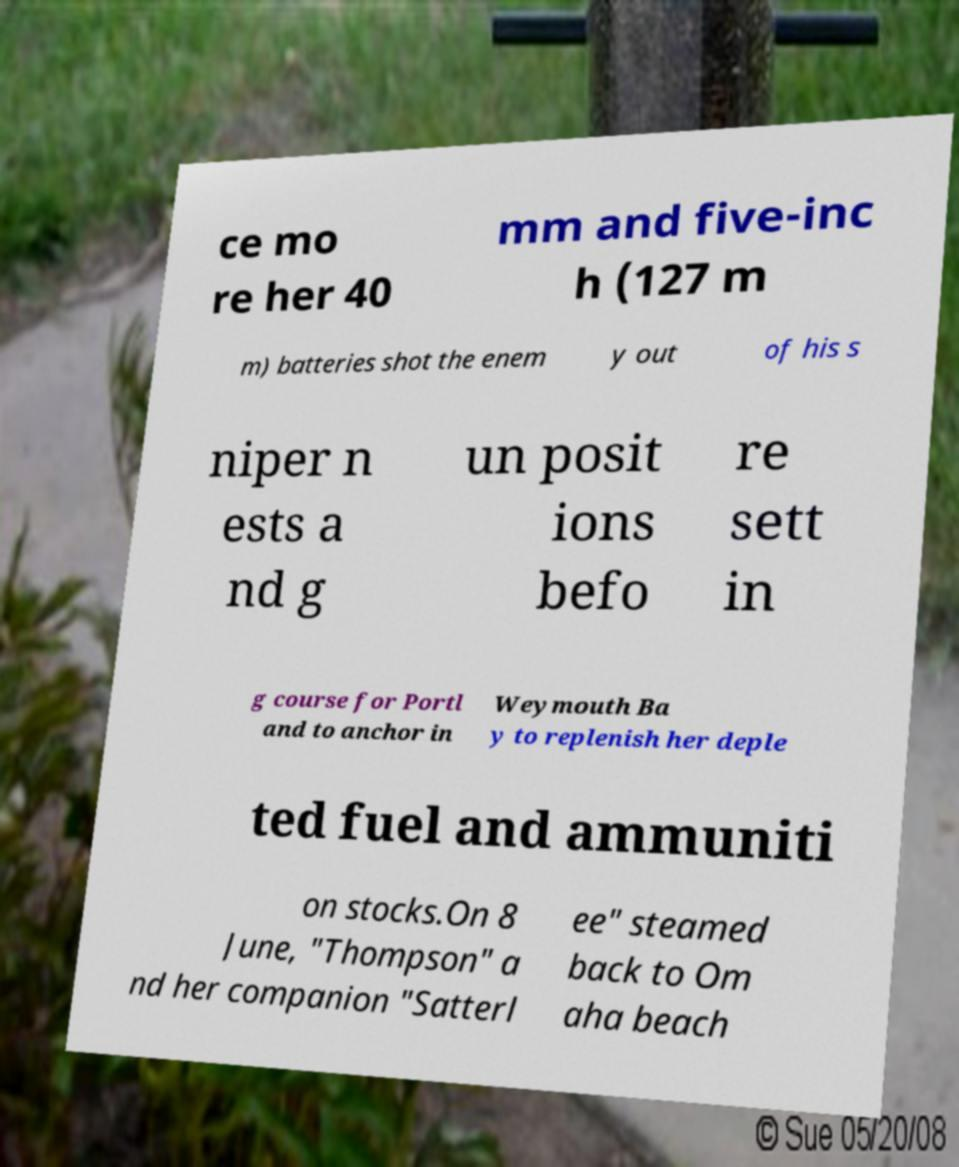There's text embedded in this image that I need extracted. Can you transcribe it verbatim? ce mo re her 40 mm and five-inc h (127 m m) batteries shot the enem y out of his s niper n ests a nd g un posit ions befo re sett in g course for Portl and to anchor in Weymouth Ba y to replenish her deple ted fuel and ammuniti on stocks.On 8 June, "Thompson" a nd her companion "Satterl ee" steamed back to Om aha beach 